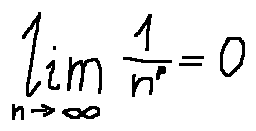Convert formula to latex. <formula><loc_0><loc_0><loc_500><loc_500>\lim \lim i t s _ { n \rightarrow \infty } \frac { 1 } { n ^ { p } } = 0</formula> 